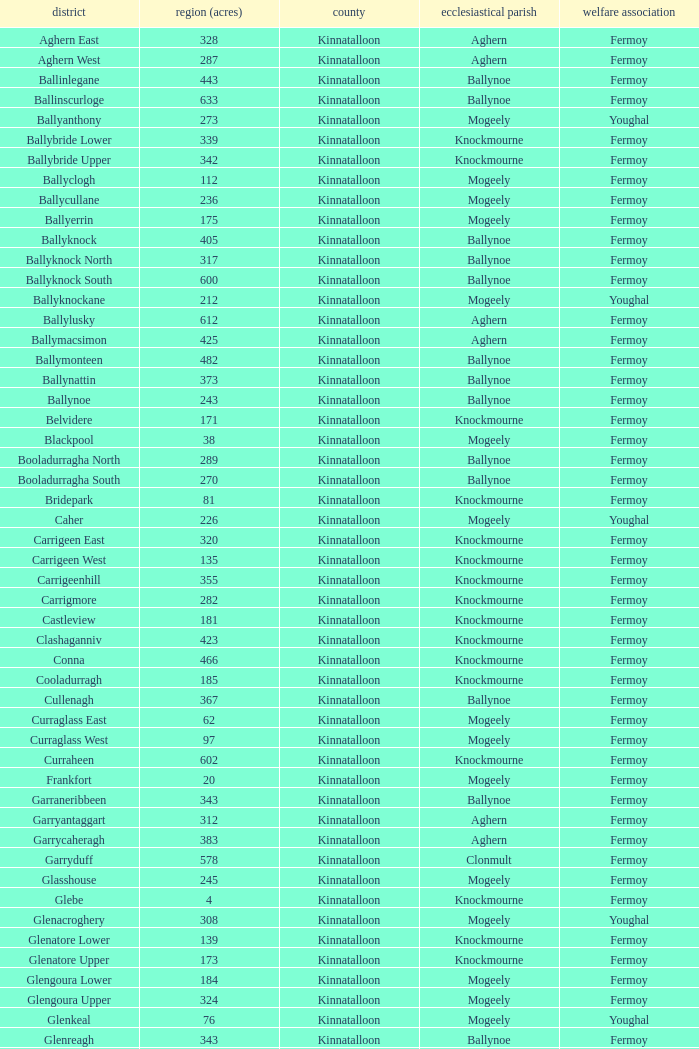Name the civil parish for garryduff Clonmult. 